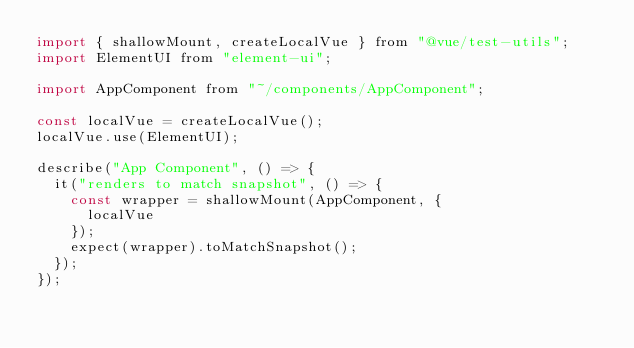<code> <loc_0><loc_0><loc_500><loc_500><_JavaScript_>import { shallowMount, createLocalVue } from "@vue/test-utils";
import ElementUI from "element-ui";

import AppComponent from "~/components/AppComponent";

const localVue = createLocalVue();
localVue.use(ElementUI);

describe("App Component", () => {
  it("renders to match snapshot", () => {
    const wrapper = shallowMount(AppComponent, {
      localVue
    });
    expect(wrapper).toMatchSnapshot();
  });
});
</code> 